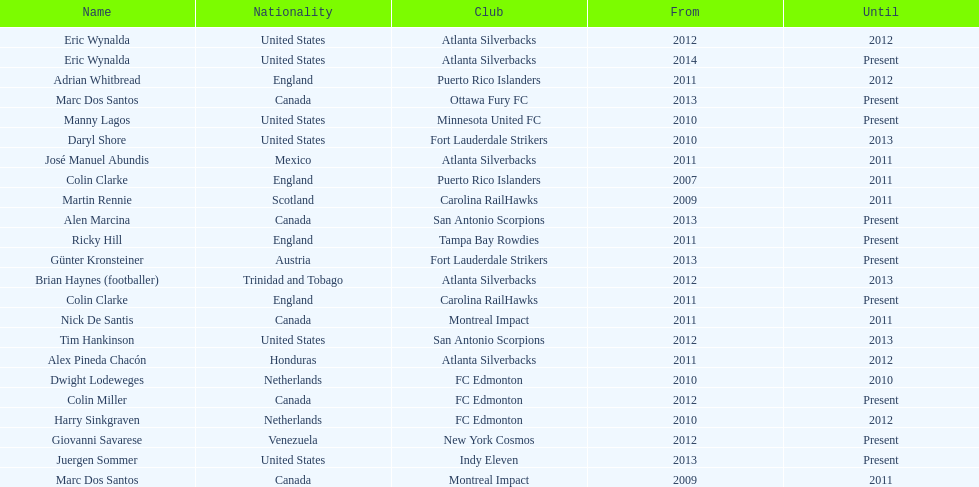How many coaches have coached from america? 6. 